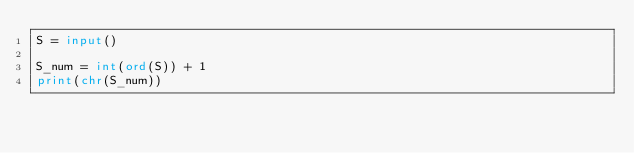Convert code to text. <code><loc_0><loc_0><loc_500><loc_500><_Python_>S = input()

S_num = int(ord(S)) + 1
print(chr(S_num))</code> 